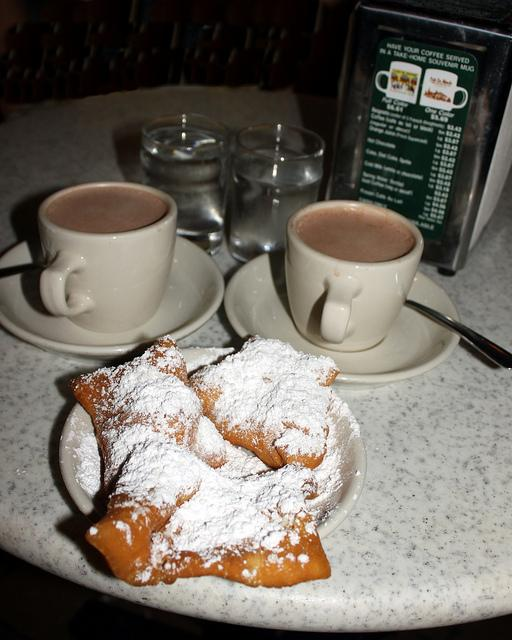What is in the tin box? napkins 